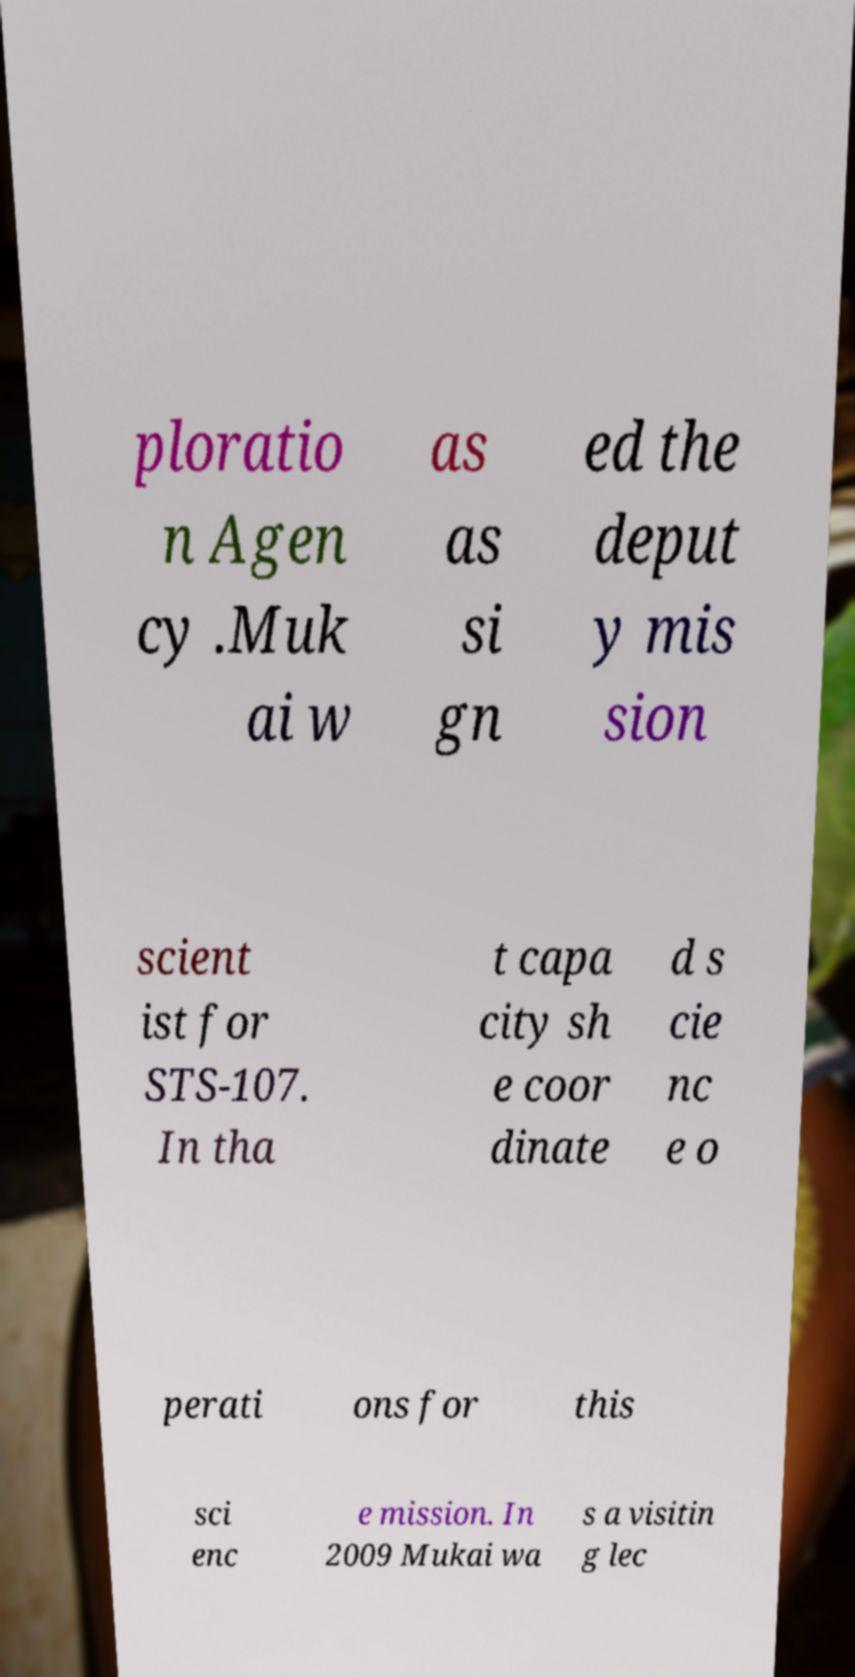Can you accurately transcribe the text from the provided image for me? ploratio n Agen cy .Muk ai w as as si gn ed the deput y mis sion scient ist for STS-107. In tha t capa city sh e coor dinate d s cie nc e o perati ons for this sci enc e mission. In 2009 Mukai wa s a visitin g lec 